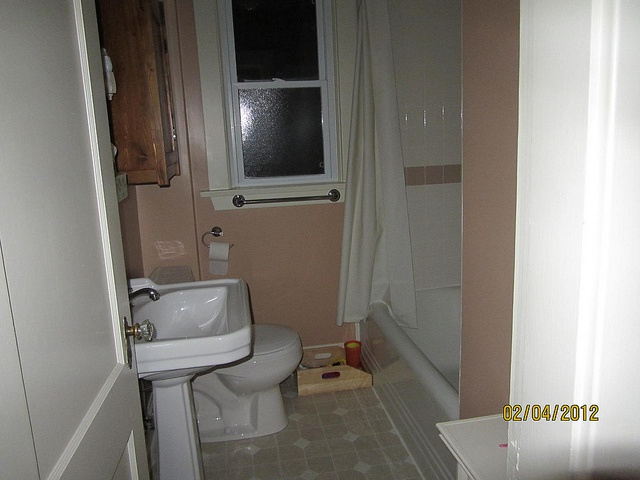Describe the objects in this image and their specific colors. I can see sink in gray, darkgray, black, and lightgray tones, toilet in gray and black tones, and cup in gray, maroon, and olive tones in this image. 